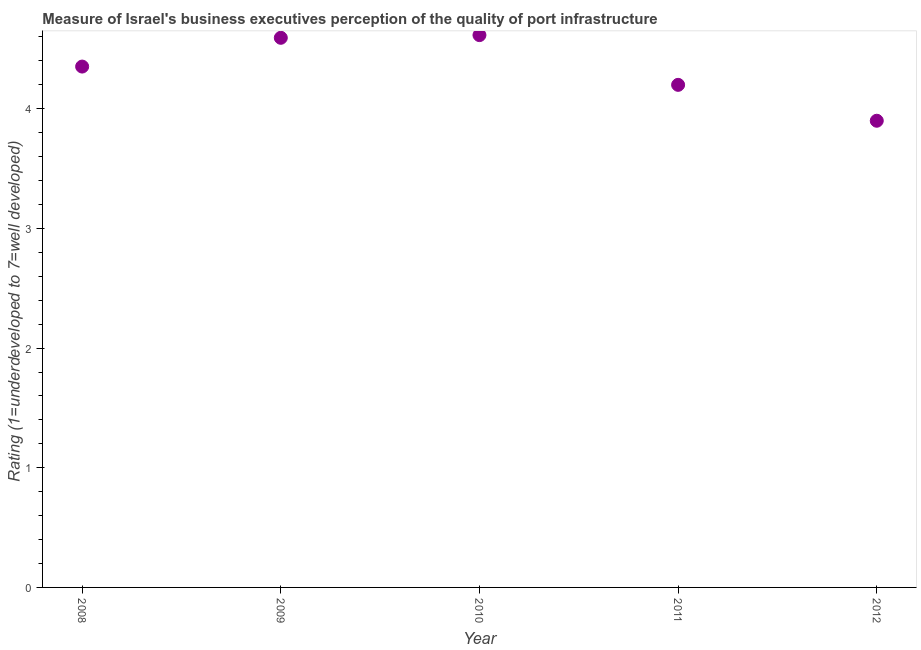What is the rating measuring quality of port infrastructure in 2008?
Provide a short and direct response. 4.35. Across all years, what is the maximum rating measuring quality of port infrastructure?
Your response must be concise. 4.62. Across all years, what is the minimum rating measuring quality of port infrastructure?
Offer a terse response. 3.9. In which year was the rating measuring quality of port infrastructure maximum?
Give a very brief answer. 2010. In which year was the rating measuring quality of port infrastructure minimum?
Offer a terse response. 2012. What is the sum of the rating measuring quality of port infrastructure?
Your response must be concise. 21.66. What is the difference between the rating measuring quality of port infrastructure in 2008 and 2009?
Make the answer very short. -0.24. What is the average rating measuring quality of port infrastructure per year?
Offer a very short reply. 4.33. What is the median rating measuring quality of port infrastructure?
Provide a short and direct response. 4.35. In how many years, is the rating measuring quality of port infrastructure greater than 3 ?
Provide a succinct answer. 5. What is the ratio of the rating measuring quality of port infrastructure in 2010 to that in 2012?
Your answer should be very brief. 1.18. Is the difference between the rating measuring quality of port infrastructure in 2010 and 2012 greater than the difference between any two years?
Your answer should be compact. Yes. What is the difference between the highest and the second highest rating measuring quality of port infrastructure?
Offer a terse response. 0.02. Is the sum of the rating measuring quality of port infrastructure in 2008 and 2009 greater than the maximum rating measuring quality of port infrastructure across all years?
Provide a succinct answer. Yes. What is the difference between the highest and the lowest rating measuring quality of port infrastructure?
Give a very brief answer. 0.72. In how many years, is the rating measuring quality of port infrastructure greater than the average rating measuring quality of port infrastructure taken over all years?
Your answer should be very brief. 3. Does the rating measuring quality of port infrastructure monotonically increase over the years?
Offer a very short reply. No. How many dotlines are there?
Offer a terse response. 1. What is the difference between two consecutive major ticks on the Y-axis?
Offer a very short reply. 1. What is the title of the graph?
Make the answer very short. Measure of Israel's business executives perception of the quality of port infrastructure. What is the label or title of the Y-axis?
Your answer should be very brief. Rating (1=underdeveloped to 7=well developed) . What is the Rating (1=underdeveloped to 7=well developed)  in 2008?
Ensure brevity in your answer.  4.35. What is the Rating (1=underdeveloped to 7=well developed)  in 2009?
Your answer should be very brief. 4.59. What is the Rating (1=underdeveloped to 7=well developed)  in 2010?
Provide a succinct answer. 4.62. What is the Rating (1=underdeveloped to 7=well developed)  in 2011?
Offer a terse response. 4.2. What is the difference between the Rating (1=underdeveloped to 7=well developed)  in 2008 and 2009?
Provide a succinct answer. -0.24. What is the difference between the Rating (1=underdeveloped to 7=well developed)  in 2008 and 2010?
Your response must be concise. -0.26. What is the difference between the Rating (1=underdeveloped to 7=well developed)  in 2008 and 2011?
Keep it short and to the point. 0.15. What is the difference between the Rating (1=underdeveloped to 7=well developed)  in 2008 and 2012?
Provide a short and direct response. 0.45. What is the difference between the Rating (1=underdeveloped to 7=well developed)  in 2009 and 2010?
Your answer should be very brief. -0.02. What is the difference between the Rating (1=underdeveloped to 7=well developed)  in 2009 and 2011?
Make the answer very short. 0.39. What is the difference between the Rating (1=underdeveloped to 7=well developed)  in 2009 and 2012?
Your response must be concise. 0.69. What is the difference between the Rating (1=underdeveloped to 7=well developed)  in 2010 and 2011?
Offer a terse response. 0.42. What is the difference between the Rating (1=underdeveloped to 7=well developed)  in 2010 and 2012?
Make the answer very short. 0.72. What is the difference between the Rating (1=underdeveloped to 7=well developed)  in 2011 and 2012?
Your response must be concise. 0.3. What is the ratio of the Rating (1=underdeveloped to 7=well developed)  in 2008 to that in 2009?
Provide a succinct answer. 0.95. What is the ratio of the Rating (1=underdeveloped to 7=well developed)  in 2008 to that in 2010?
Give a very brief answer. 0.94. What is the ratio of the Rating (1=underdeveloped to 7=well developed)  in 2008 to that in 2011?
Keep it short and to the point. 1.04. What is the ratio of the Rating (1=underdeveloped to 7=well developed)  in 2008 to that in 2012?
Provide a succinct answer. 1.12. What is the ratio of the Rating (1=underdeveloped to 7=well developed)  in 2009 to that in 2010?
Ensure brevity in your answer.  0.99. What is the ratio of the Rating (1=underdeveloped to 7=well developed)  in 2009 to that in 2011?
Keep it short and to the point. 1.09. What is the ratio of the Rating (1=underdeveloped to 7=well developed)  in 2009 to that in 2012?
Ensure brevity in your answer.  1.18. What is the ratio of the Rating (1=underdeveloped to 7=well developed)  in 2010 to that in 2011?
Provide a succinct answer. 1.1. What is the ratio of the Rating (1=underdeveloped to 7=well developed)  in 2010 to that in 2012?
Give a very brief answer. 1.18. What is the ratio of the Rating (1=underdeveloped to 7=well developed)  in 2011 to that in 2012?
Your answer should be very brief. 1.08. 